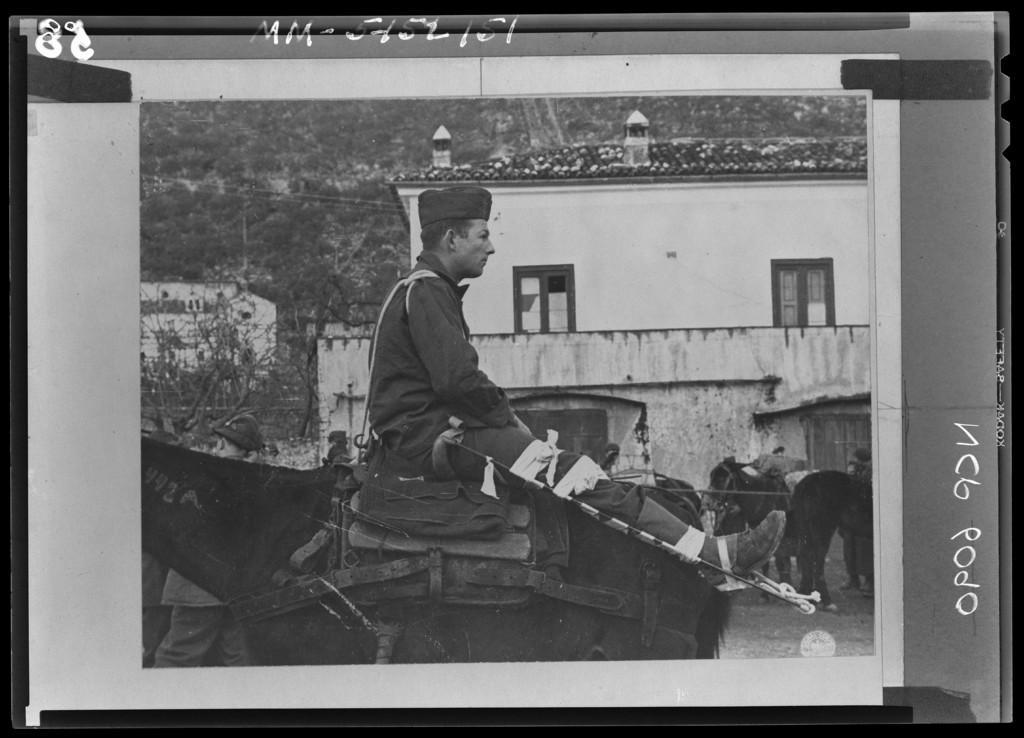Could you give a brief overview of what you see in this image? This is a black and white photo. In this photo there is a person sitting on the horse, behind the horse there are few people walking and there are few horses. In the background there is a building and trees. 